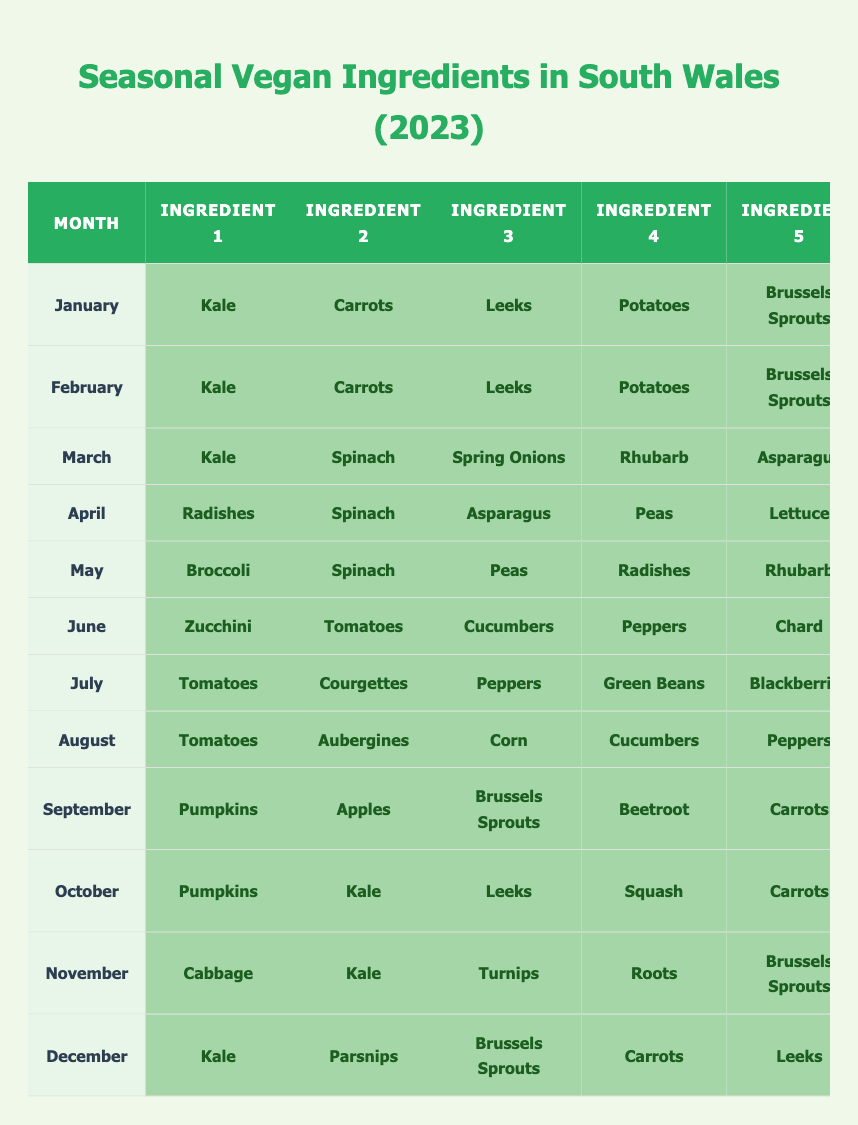What ingredients are available in March? In March, the ingredients listed as available are Kale, Spinach, Spring Onions, Rhubarb, Asparagus, and Potatoes. This can be found by locating March in the table and reading across the corresponding row.
Answer: Kale, Spinach, Spring Onions, Rhubarb, Asparagus, Potatoes Which month has the highest number of available ingredients? To find the month with the highest number of available ingredients, count the number of ingredients listed for each month. April, May, June, July, and August each have 6 available ingredients, which is the highest.
Answer: April, May, June, July, August Is Beetroot available in October? Beetroot is not listed as available in October. By checking the table, you can see that beetroot appears only in February.
Answer: No How many months have Kale available? Kale is available in January, February, March, September, October, November, and December. Count the occurrences in each of these months for the total. There are 7 months where Kale is available.
Answer: 7 In which month can you find both Tomatoes and Peppers? Tomatoes and Peppers are available in June, July, and August. First, check the ingredients listed for these months and identify where both are present.
Answer: June, July, August What is the total count of ingredients available in November? In November, there are 6 available ingredients: Cabbage, Kale, Turnips, Roots, Brussels Sprouts, and Potatoes. Total them by just counting each ingredient provided for November.
Answer: 6 Which ingredient is available in every month? By reviewing the ingredients listed for all twelve months, we can see that Kale appears in every month, while other ingredients do not. This requires looking at each month's entries.
Answer: Kale How many different ingredients are available in the summer months (June, July, August)? The ingredients available during summer months are Zucchini, Tomatoes, Cucumbers, Peppers, Chard, and Basil in June; Tomatoes, Courgettes, Peppers, Green Beans, Blackberries, and Herbs in July; and Tomatoes, Aubergines, Corn, Cucumbers, Peppers, and Figs in August. List all unique ingredients across these months and count them.
Answer: 12 